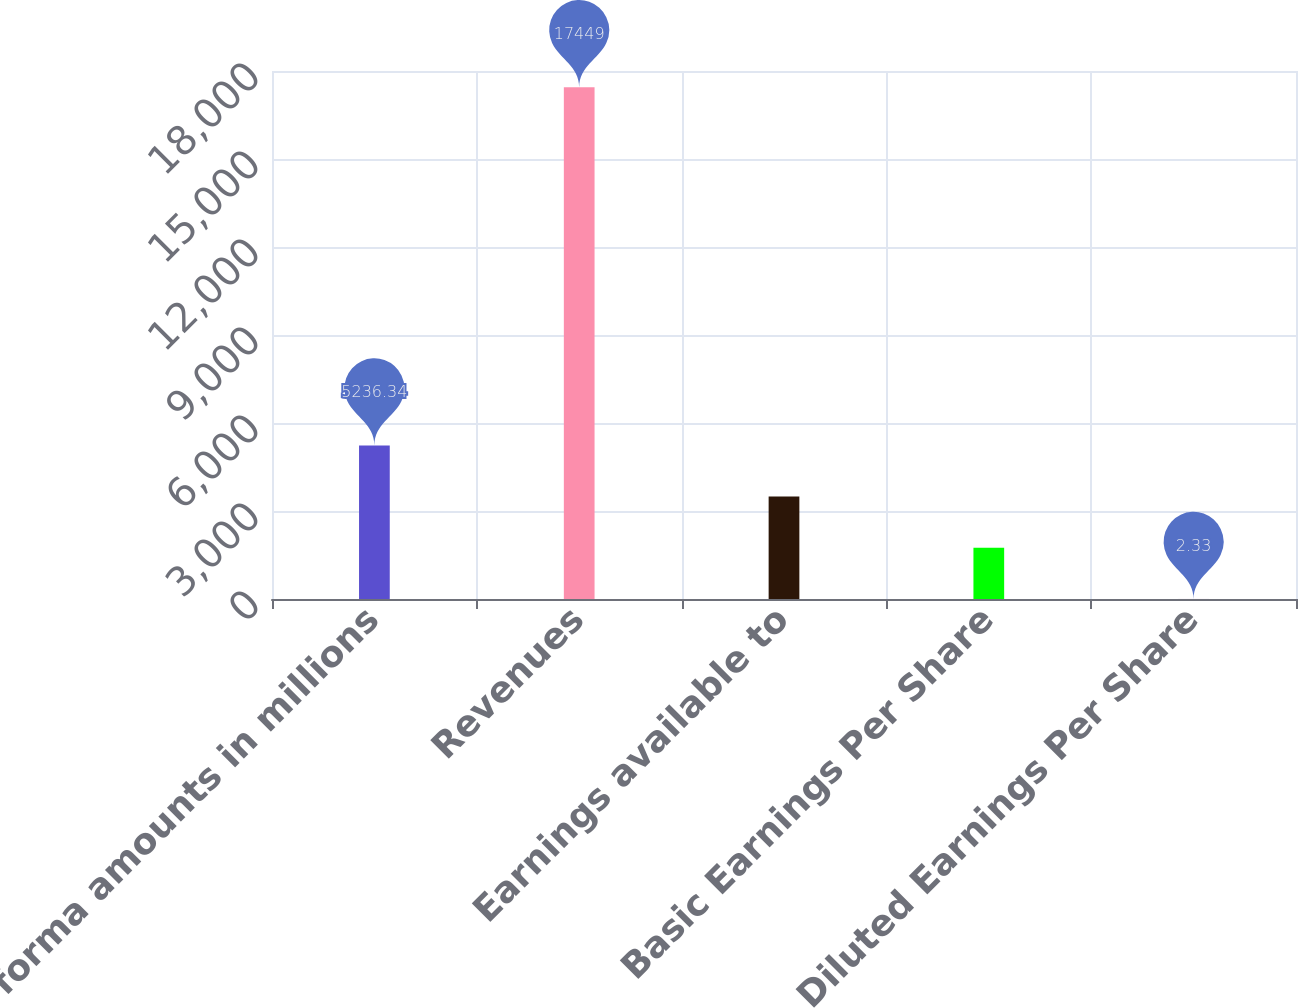Convert chart. <chart><loc_0><loc_0><loc_500><loc_500><bar_chart><fcel>(Pro forma amounts in millions<fcel>Revenues<fcel>Earnings available to<fcel>Basic Earnings Per Share<fcel>Diluted Earnings Per Share<nl><fcel>5236.34<fcel>17449<fcel>3491.67<fcel>1747<fcel>2.33<nl></chart> 